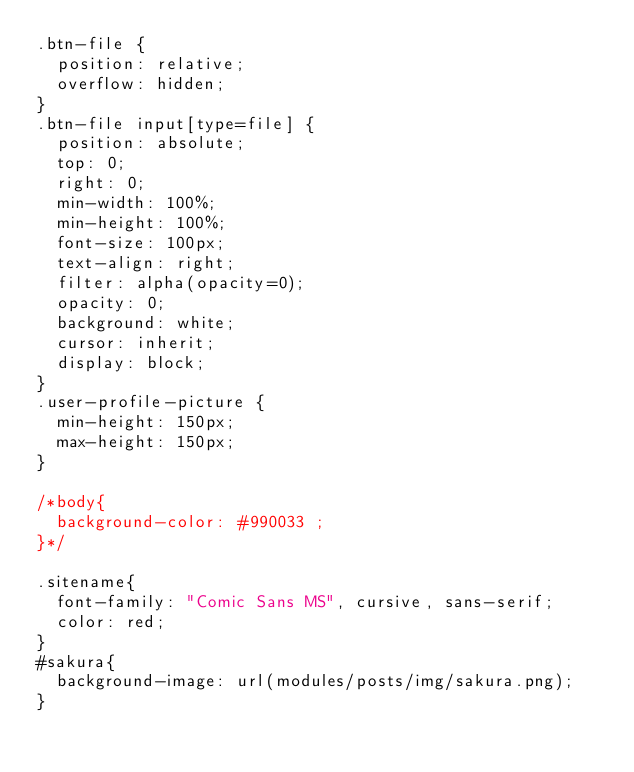Convert code to text. <code><loc_0><loc_0><loc_500><loc_500><_CSS_>.btn-file {
  position: relative;
  overflow: hidden;
}
.btn-file input[type=file] {
  position: absolute;
  top: 0;
  right: 0;
  min-width: 100%;
  min-height: 100%;
  font-size: 100px;
  text-align: right;
  filter: alpha(opacity=0);
  opacity: 0;
  background: white;
  cursor: inherit;
  display: block;
}
.user-profile-picture {
  min-height: 150px;
  max-height: 150px;
}

/*body{
  background-color: #990033 ;
}*/

.sitename{
  font-family: "Comic Sans MS", cursive, sans-serif;
  color: red;
}
#sakura{
  background-image: url(modules/posts/img/sakura.png);
}

</code> 